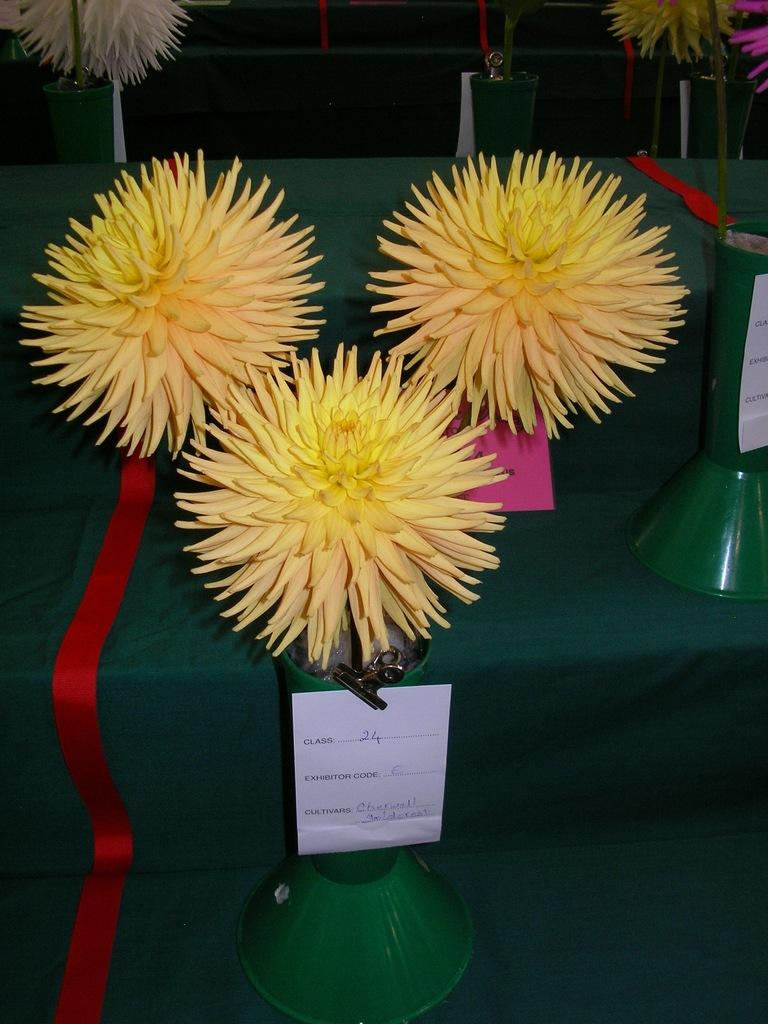What type of objects can be seen in the image? There are flower vases and information boards in the image. Can you describe the purpose of the information boards? The information boards are likely used for displaying information or directions. What type of lace can be seen on the flower vases in the image? There is no lace present on the flower vases in the image. How do the information boards move around in the image? The information boards do not move around in the image; they are stationary. 